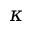<formula> <loc_0><loc_0><loc_500><loc_500>\kappa</formula> 